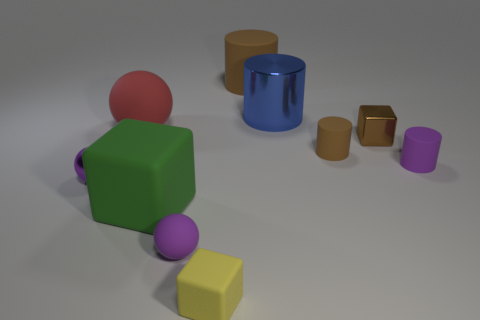How would you describe the lighting and mood of this image? The lighting in the image is soft and diffused, giving the scene a calm and serene atmosphere. Shadows are soft-edged and not overly pronounced, which contributes to the overall tranquil mood without strong emotional overtones. Do the spatial arrangements suggest anything to you? The spatial arrangement seems to be carefully balanced, with objects placed in a way that creates visual harmony. It doesn't appear to convey a specific narrative, but the distances between objects can be seen to suggest neutrality, with no single object dominating the scene. 